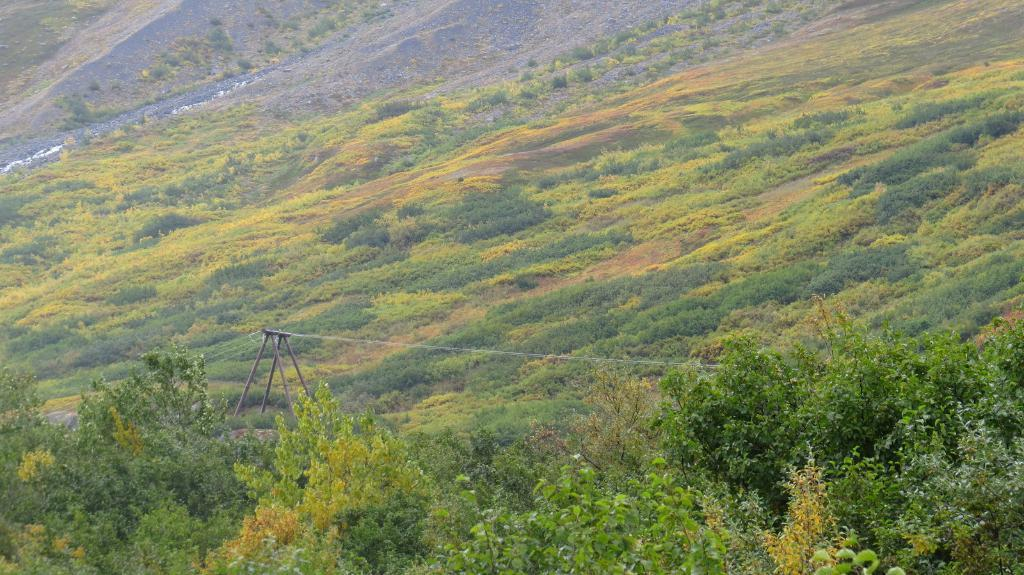What type of vegetation can be seen in the image? There are trees in the image. What part of the natural environment is visible in the image? The ground is visible in the image. What is the condition of the ground in the image? The ground has greenery. What color is the wax on the trees in the image? There is no wax present on the trees in the image. How many balloons are tied to the branches of the trees in the image? There are no balloons present in the image. 